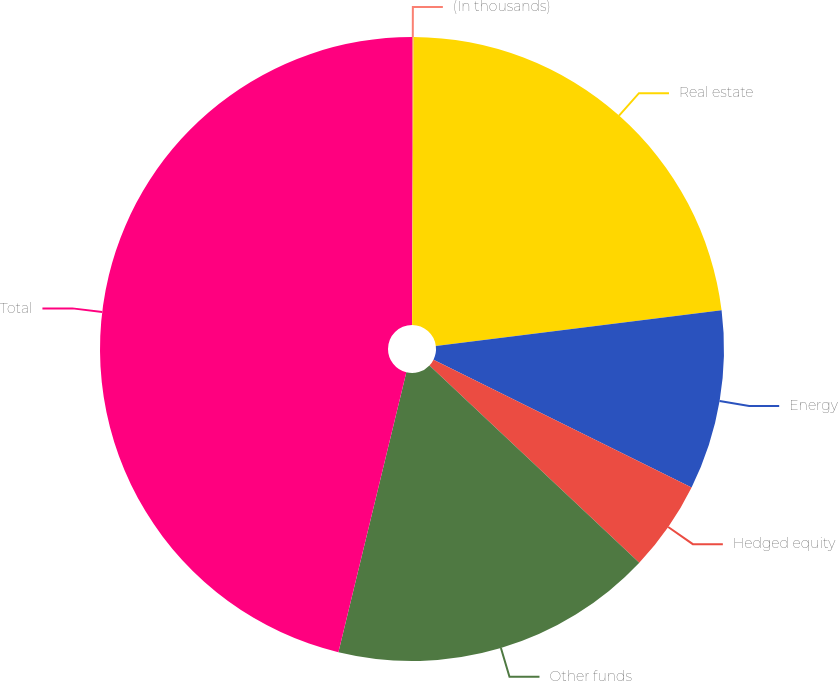Convert chart to OTSL. <chart><loc_0><loc_0><loc_500><loc_500><pie_chart><fcel>(In thousands)<fcel>Real estate<fcel>Energy<fcel>Hedged equity<fcel>Other funds<fcel>Total<nl><fcel>0.08%<fcel>22.94%<fcel>9.3%<fcel>4.69%<fcel>16.78%<fcel>46.21%<nl></chart> 